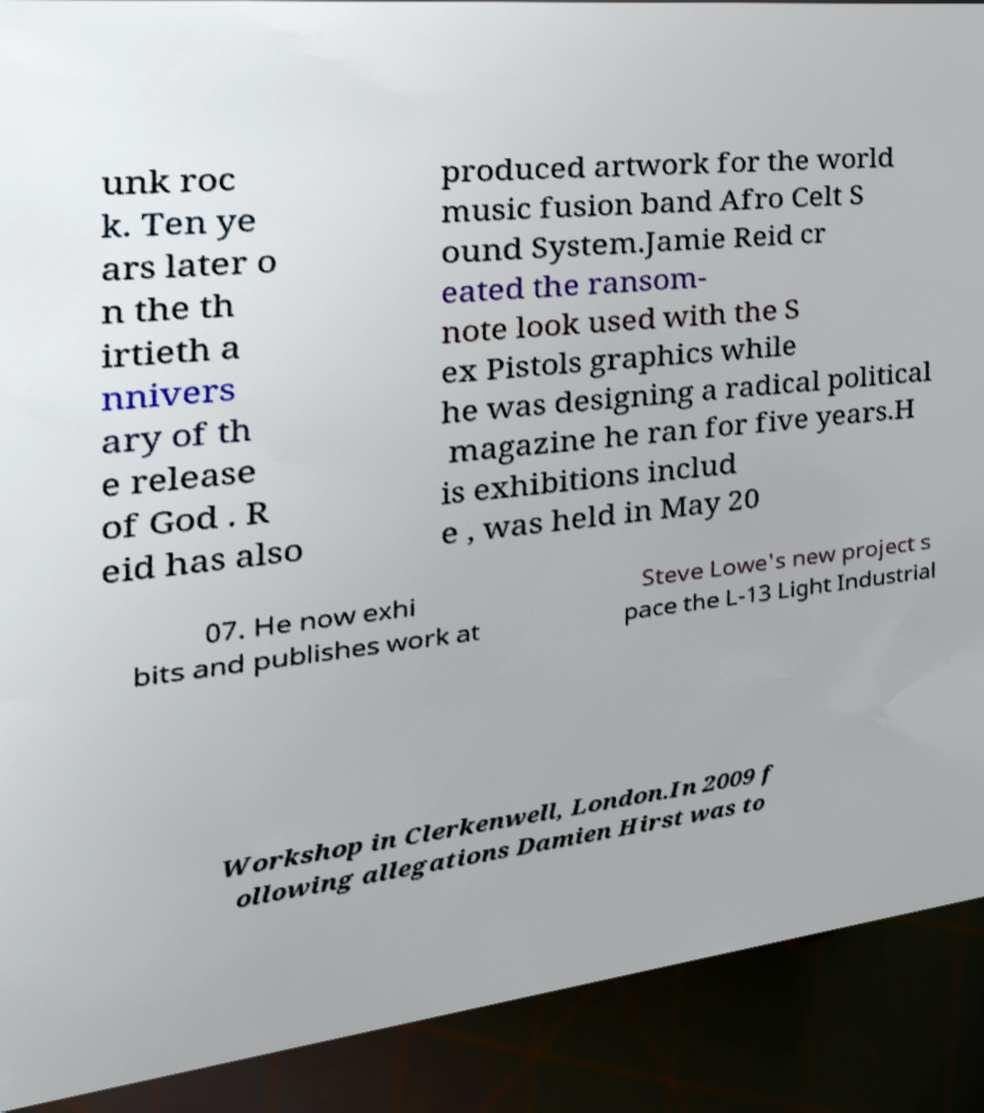Could you extract and type out the text from this image? unk roc k. Ten ye ars later o n the th irtieth a nnivers ary of th e release of God . R eid has also produced artwork for the world music fusion band Afro Celt S ound System.Jamie Reid cr eated the ransom- note look used with the S ex Pistols graphics while he was designing a radical political magazine he ran for five years.H is exhibitions includ e , was held in May 20 07. He now exhi bits and publishes work at Steve Lowe's new project s pace the L-13 Light Industrial Workshop in Clerkenwell, London.In 2009 f ollowing allegations Damien Hirst was to 